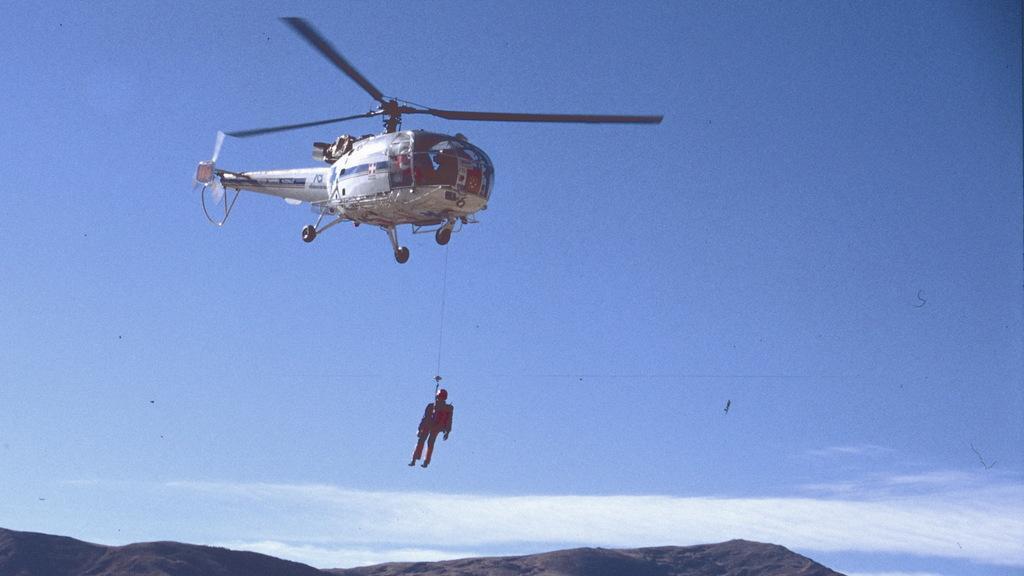Could you give a brief overview of what you see in this image? In the background we can see the sky. In this picture we can see a helicopter. We can see a person is in the air with the help of a rope. At the bottom portion of the picture we can see hills. 